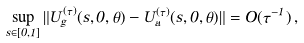<formula> <loc_0><loc_0><loc_500><loc_500>\sup _ { s \in [ 0 , 1 ] } \| U ^ { ( \tau ) } _ { g } ( s , 0 , \theta ) - U ^ { ( \tau ) } _ { a } ( s , 0 , \theta ) \| = O ( \tau ^ { - 1 } ) \, ,</formula> 